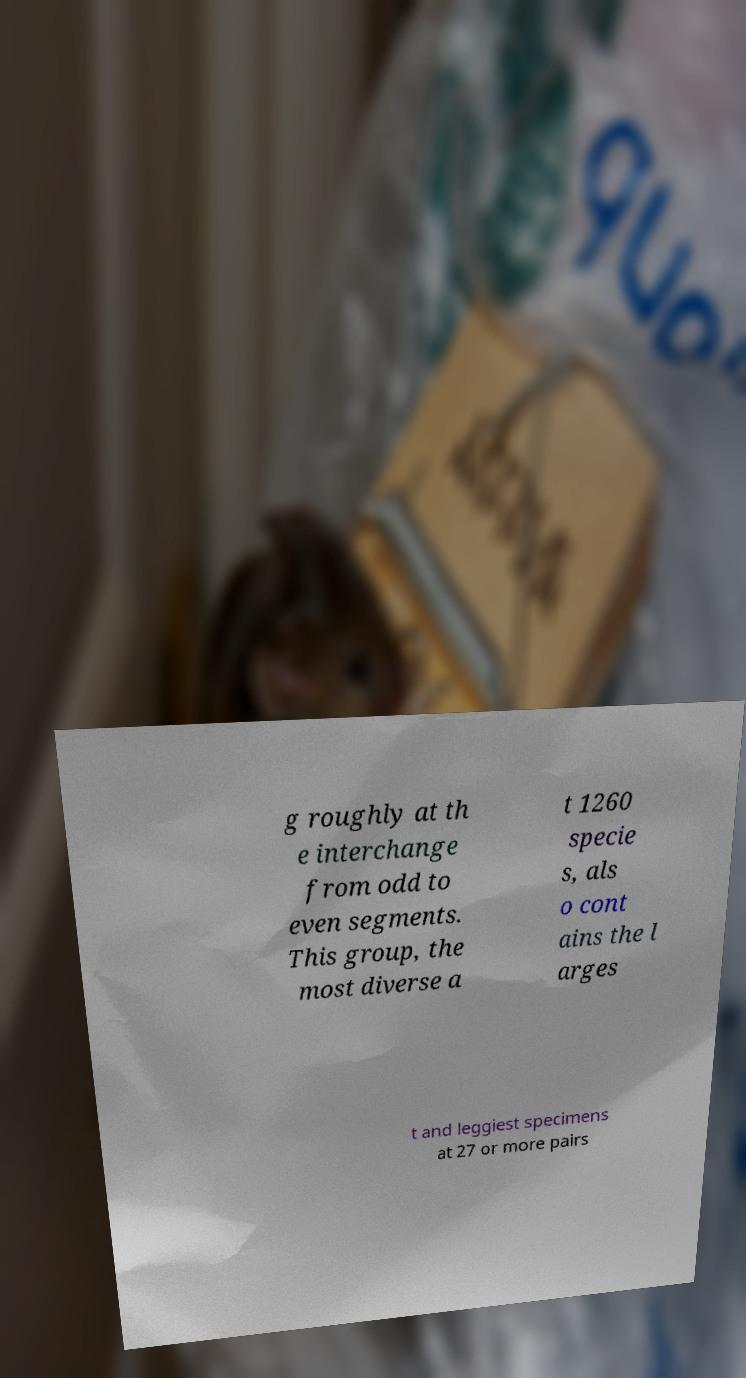Please read and relay the text visible in this image. What does it say? g roughly at th e interchange from odd to even segments. This group, the most diverse a t 1260 specie s, als o cont ains the l arges t and leggiest specimens at 27 or more pairs 